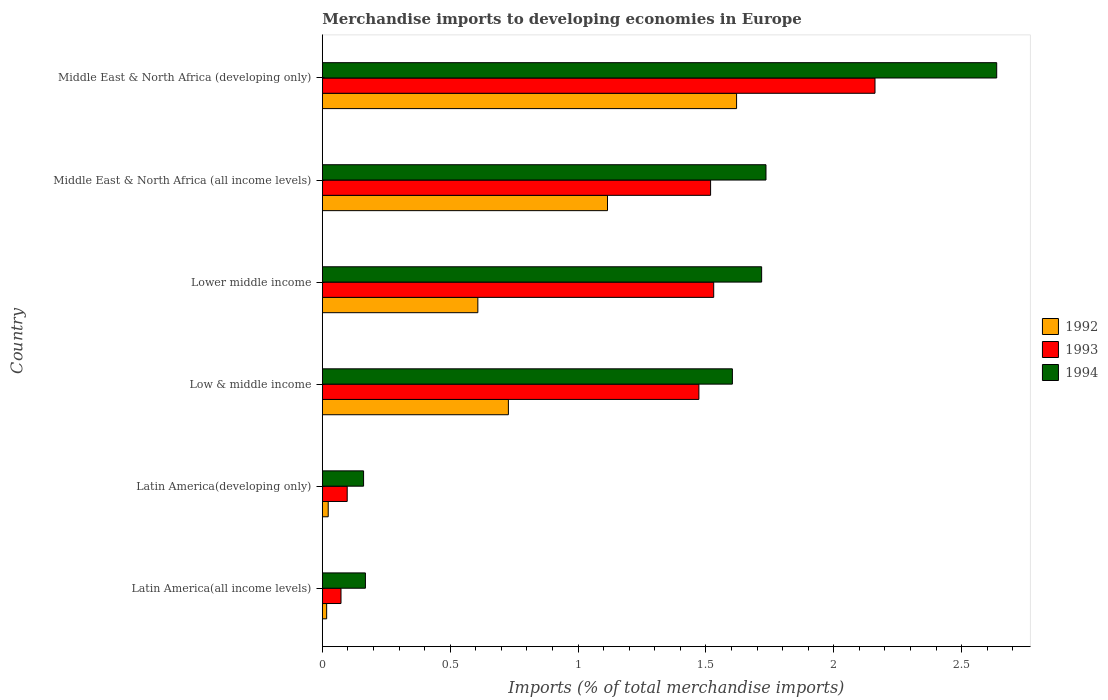How many different coloured bars are there?
Make the answer very short. 3. How many groups of bars are there?
Ensure brevity in your answer.  6. Are the number of bars per tick equal to the number of legend labels?
Ensure brevity in your answer.  Yes. How many bars are there on the 6th tick from the top?
Make the answer very short. 3. How many bars are there on the 3rd tick from the bottom?
Your response must be concise. 3. What is the label of the 3rd group of bars from the top?
Your response must be concise. Lower middle income. In how many cases, is the number of bars for a given country not equal to the number of legend labels?
Your answer should be very brief. 0. What is the percentage total merchandise imports in 1993 in Low & middle income?
Offer a very short reply. 1.47. Across all countries, what is the maximum percentage total merchandise imports in 1993?
Ensure brevity in your answer.  2.16. Across all countries, what is the minimum percentage total merchandise imports in 1994?
Provide a succinct answer. 0.16. In which country was the percentage total merchandise imports in 1994 maximum?
Offer a terse response. Middle East & North Africa (developing only). In which country was the percentage total merchandise imports in 1993 minimum?
Provide a short and direct response. Latin America(all income levels). What is the total percentage total merchandise imports in 1993 in the graph?
Your answer should be very brief. 6.85. What is the difference between the percentage total merchandise imports in 1992 in Middle East & North Africa (all income levels) and that in Middle East & North Africa (developing only)?
Give a very brief answer. -0.5. What is the difference between the percentage total merchandise imports in 1992 in Lower middle income and the percentage total merchandise imports in 1994 in Latin America(all income levels)?
Offer a very short reply. 0.44. What is the average percentage total merchandise imports in 1992 per country?
Ensure brevity in your answer.  0.69. What is the difference between the percentage total merchandise imports in 1994 and percentage total merchandise imports in 1992 in Latin America(all income levels)?
Offer a very short reply. 0.15. In how many countries, is the percentage total merchandise imports in 1992 greater than 0.5 %?
Give a very brief answer. 4. What is the ratio of the percentage total merchandise imports in 1993 in Lower middle income to that in Middle East & North Africa (developing only)?
Ensure brevity in your answer.  0.71. What is the difference between the highest and the second highest percentage total merchandise imports in 1994?
Provide a succinct answer. 0.9. What is the difference between the highest and the lowest percentage total merchandise imports in 1993?
Ensure brevity in your answer.  2.09. In how many countries, is the percentage total merchandise imports in 1993 greater than the average percentage total merchandise imports in 1993 taken over all countries?
Keep it short and to the point. 4. Is the sum of the percentage total merchandise imports in 1992 in Latin America(all income levels) and Low & middle income greater than the maximum percentage total merchandise imports in 1994 across all countries?
Make the answer very short. No. Is it the case that in every country, the sum of the percentage total merchandise imports in 1993 and percentage total merchandise imports in 1994 is greater than the percentage total merchandise imports in 1992?
Keep it short and to the point. Yes. How many bars are there?
Ensure brevity in your answer.  18. Are all the bars in the graph horizontal?
Make the answer very short. Yes. What is the difference between two consecutive major ticks on the X-axis?
Provide a short and direct response. 0.5. Does the graph contain grids?
Ensure brevity in your answer.  No. How many legend labels are there?
Offer a terse response. 3. What is the title of the graph?
Your response must be concise. Merchandise imports to developing economies in Europe. What is the label or title of the X-axis?
Offer a very short reply. Imports (% of total merchandise imports). What is the Imports (% of total merchandise imports) in 1992 in Latin America(all income levels)?
Keep it short and to the point. 0.02. What is the Imports (% of total merchandise imports) of 1993 in Latin America(all income levels)?
Give a very brief answer. 0.07. What is the Imports (% of total merchandise imports) in 1994 in Latin America(all income levels)?
Provide a short and direct response. 0.17. What is the Imports (% of total merchandise imports) of 1992 in Latin America(developing only)?
Your response must be concise. 0.02. What is the Imports (% of total merchandise imports) of 1993 in Latin America(developing only)?
Offer a terse response. 0.1. What is the Imports (% of total merchandise imports) in 1994 in Latin America(developing only)?
Offer a terse response. 0.16. What is the Imports (% of total merchandise imports) of 1992 in Low & middle income?
Make the answer very short. 0.73. What is the Imports (% of total merchandise imports) of 1993 in Low & middle income?
Offer a terse response. 1.47. What is the Imports (% of total merchandise imports) in 1994 in Low & middle income?
Your answer should be compact. 1.6. What is the Imports (% of total merchandise imports) of 1992 in Lower middle income?
Provide a succinct answer. 0.61. What is the Imports (% of total merchandise imports) in 1993 in Lower middle income?
Offer a very short reply. 1.53. What is the Imports (% of total merchandise imports) of 1994 in Lower middle income?
Make the answer very short. 1.72. What is the Imports (% of total merchandise imports) in 1992 in Middle East & North Africa (all income levels)?
Provide a succinct answer. 1.12. What is the Imports (% of total merchandise imports) of 1993 in Middle East & North Africa (all income levels)?
Make the answer very short. 1.52. What is the Imports (% of total merchandise imports) of 1994 in Middle East & North Africa (all income levels)?
Give a very brief answer. 1.74. What is the Imports (% of total merchandise imports) of 1992 in Middle East & North Africa (developing only)?
Offer a very short reply. 1.62. What is the Imports (% of total merchandise imports) in 1993 in Middle East & North Africa (developing only)?
Offer a terse response. 2.16. What is the Imports (% of total merchandise imports) of 1994 in Middle East & North Africa (developing only)?
Provide a succinct answer. 2.64. Across all countries, what is the maximum Imports (% of total merchandise imports) in 1992?
Provide a succinct answer. 1.62. Across all countries, what is the maximum Imports (% of total merchandise imports) in 1993?
Make the answer very short. 2.16. Across all countries, what is the maximum Imports (% of total merchandise imports) in 1994?
Provide a succinct answer. 2.64. Across all countries, what is the minimum Imports (% of total merchandise imports) of 1992?
Provide a succinct answer. 0.02. Across all countries, what is the minimum Imports (% of total merchandise imports) in 1993?
Your response must be concise. 0.07. Across all countries, what is the minimum Imports (% of total merchandise imports) of 1994?
Keep it short and to the point. 0.16. What is the total Imports (% of total merchandise imports) of 1992 in the graph?
Make the answer very short. 4.11. What is the total Imports (% of total merchandise imports) of 1993 in the graph?
Offer a terse response. 6.85. What is the total Imports (% of total merchandise imports) of 1994 in the graph?
Your answer should be very brief. 8.02. What is the difference between the Imports (% of total merchandise imports) of 1992 in Latin America(all income levels) and that in Latin America(developing only)?
Keep it short and to the point. -0.01. What is the difference between the Imports (% of total merchandise imports) in 1993 in Latin America(all income levels) and that in Latin America(developing only)?
Your answer should be compact. -0.02. What is the difference between the Imports (% of total merchandise imports) in 1994 in Latin America(all income levels) and that in Latin America(developing only)?
Provide a succinct answer. 0.01. What is the difference between the Imports (% of total merchandise imports) of 1992 in Latin America(all income levels) and that in Low & middle income?
Offer a terse response. -0.71. What is the difference between the Imports (% of total merchandise imports) of 1993 in Latin America(all income levels) and that in Low & middle income?
Provide a short and direct response. -1.4. What is the difference between the Imports (% of total merchandise imports) of 1994 in Latin America(all income levels) and that in Low & middle income?
Your answer should be very brief. -1.44. What is the difference between the Imports (% of total merchandise imports) in 1992 in Latin America(all income levels) and that in Lower middle income?
Offer a terse response. -0.59. What is the difference between the Imports (% of total merchandise imports) in 1993 in Latin America(all income levels) and that in Lower middle income?
Your response must be concise. -1.46. What is the difference between the Imports (% of total merchandise imports) in 1994 in Latin America(all income levels) and that in Lower middle income?
Provide a short and direct response. -1.55. What is the difference between the Imports (% of total merchandise imports) in 1992 in Latin America(all income levels) and that in Middle East & North Africa (all income levels)?
Keep it short and to the point. -1.1. What is the difference between the Imports (% of total merchandise imports) of 1993 in Latin America(all income levels) and that in Middle East & North Africa (all income levels)?
Provide a succinct answer. -1.45. What is the difference between the Imports (% of total merchandise imports) of 1994 in Latin America(all income levels) and that in Middle East & North Africa (all income levels)?
Your answer should be very brief. -1.57. What is the difference between the Imports (% of total merchandise imports) in 1992 in Latin America(all income levels) and that in Middle East & North Africa (developing only)?
Your answer should be compact. -1.6. What is the difference between the Imports (% of total merchandise imports) of 1993 in Latin America(all income levels) and that in Middle East & North Africa (developing only)?
Provide a succinct answer. -2.09. What is the difference between the Imports (% of total merchandise imports) in 1994 in Latin America(all income levels) and that in Middle East & North Africa (developing only)?
Keep it short and to the point. -2.47. What is the difference between the Imports (% of total merchandise imports) of 1992 in Latin America(developing only) and that in Low & middle income?
Keep it short and to the point. -0.7. What is the difference between the Imports (% of total merchandise imports) of 1993 in Latin America(developing only) and that in Low & middle income?
Provide a succinct answer. -1.38. What is the difference between the Imports (% of total merchandise imports) in 1994 in Latin America(developing only) and that in Low & middle income?
Provide a succinct answer. -1.44. What is the difference between the Imports (% of total merchandise imports) of 1992 in Latin America(developing only) and that in Lower middle income?
Provide a short and direct response. -0.59. What is the difference between the Imports (% of total merchandise imports) in 1993 in Latin America(developing only) and that in Lower middle income?
Provide a succinct answer. -1.43. What is the difference between the Imports (% of total merchandise imports) in 1994 in Latin America(developing only) and that in Lower middle income?
Offer a terse response. -1.56. What is the difference between the Imports (% of total merchandise imports) in 1992 in Latin America(developing only) and that in Middle East & North Africa (all income levels)?
Provide a short and direct response. -1.09. What is the difference between the Imports (% of total merchandise imports) of 1993 in Latin America(developing only) and that in Middle East & North Africa (all income levels)?
Keep it short and to the point. -1.42. What is the difference between the Imports (% of total merchandise imports) in 1994 in Latin America(developing only) and that in Middle East & North Africa (all income levels)?
Offer a terse response. -1.57. What is the difference between the Imports (% of total merchandise imports) of 1992 in Latin America(developing only) and that in Middle East & North Africa (developing only)?
Provide a succinct answer. -1.6. What is the difference between the Imports (% of total merchandise imports) of 1993 in Latin America(developing only) and that in Middle East & North Africa (developing only)?
Keep it short and to the point. -2.06. What is the difference between the Imports (% of total merchandise imports) of 1994 in Latin America(developing only) and that in Middle East & North Africa (developing only)?
Your answer should be very brief. -2.48. What is the difference between the Imports (% of total merchandise imports) of 1992 in Low & middle income and that in Lower middle income?
Your answer should be compact. 0.12. What is the difference between the Imports (% of total merchandise imports) in 1993 in Low & middle income and that in Lower middle income?
Ensure brevity in your answer.  -0.06. What is the difference between the Imports (% of total merchandise imports) of 1994 in Low & middle income and that in Lower middle income?
Your answer should be compact. -0.11. What is the difference between the Imports (% of total merchandise imports) in 1992 in Low & middle income and that in Middle East & North Africa (all income levels)?
Offer a very short reply. -0.39. What is the difference between the Imports (% of total merchandise imports) of 1993 in Low & middle income and that in Middle East & North Africa (all income levels)?
Offer a terse response. -0.05. What is the difference between the Imports (% of total merchandise imports) of 1994 in Low & middle income and that in Middle East & North Africa (all income levels)?
Keep it short and to the point. -0.13. What is the difference between the Imports (% of total merchandise imports) in 1992 in Low & middle income and that in Middle East & North Africa (developing only)?
Keep it short and to the point. -0.89. What is the difference between the Imports (% of total merchandise imports) of 1993 in Low & middle income and that in Middle East & North Africa (developing only)?
Your answer should be very brief. -0.69. What is the difference between the Imports (% of total merchandise imports) in 1994 in Low & middle income and that in Middle East & North Africa (developing only)?
Offer a very short reply. -1.03. What is the difference between the Imports (% of total merchandise imports) in 1992 in Lower middle income and that in Middle East & North Africa (all income levels)?
Provide a short and direct response. -0.51. What is the difference between the Imports (% of total merchandise imports) in 1993 in Lower middle income and that in Middle East & North Africa (all income levels)?
Give a very brief answer. 0.01. What is the difference between the Imports (% of total merchandise imports) in 1994 in Lower middle income and that in Middle East & North Africa (all income levels)?
Give a very brief answer. -0.02. What is the difference between the Imports (% of total merchandise imports) in 1992 in Lower middle income and that in Middle East & North Africa (developing only)?
Your answer should be compact. -1.01. What is the difference between the Imports (% of total merchandise imports) in 1993 in Lower middle income and that in Middle East & North Africa (developing only)?
Provide a succinct answer. -0.63. What is the difference between the Imports (% of total merchandise imports) in 1994 in Lower middle income and that in Middle East & North Africa (developing only)?
Give a very brief answer. -0.92. What is the difference between the Imports (% of total merchandise imports) of 1992 in Middle East & North Africa (all income levels) and that in Middle East & North Africa (developing only)?
Provide a short and direct response. -0.5. What is the difference between the Imports (% of total merchandise imports) of 1993 in Middle East & North Africa (all income levels) and that in Middle East & North Africa (developing only)?
Give a very brief answer. -0.64. What is the difference between the Imports (% of total merchandise imports) in 1994 in Middle East & North Africa (all income levels) and that in Middle East & North Africa (developing only)?
Your answer should be very brief. -0.9. What is the difference between the Imports (% of total merchandise imports) of 1992 in Latin America(all income levels) and the Imports (% of total merchandise imports) of 1993 in Latin America(developing only)?
Your answer should be compact. -0.08. What is the difference between the Imports (% of total merchandise imports) of 1992 in Latin America(all income levels) and the Imports (% of total merchandise imports) of 1994 in Latin America(developing only)?
Offer a terse response. -0.14. What is the difference between the Imports (% of total merchandise imports) in 1993 in Latin America(all income levels) and the Imports (% of total merchandise imports) in 1994 in Latin America(developing only)?
Offer a very short reply. -0.09. What is the difference between the Imports (% of total merchandise imports) in 1992 in Latin America(all income levels) and the Imports (% of total merchandise imports) in 1993 in Low & middle income?
Your response must be concise. -1.46. What is the difference between the Imports (% of total merchandise imports) of 1992 in Latin America(all income levels) and the Imports (% of total merchandise imports) of 1994 in Low & middle income?
Keep it short and to the point. -1.59. What is the difference between the Imports (% of total merchandise imports) in 1993 in Latin America(all income levels) and the Imports (% of total merchandise imports) in 1994 in Low & middle income?
Your answer should be compact. -1.53. What is the difference between the Imports (% of total merchandise imports) in 1992 in Latin America(all income levels) and the Imports (% of total merchandise imports) in 1993 in Lower middle income?
Offer a very short reply. -1.51. What is the difference between the Imports (% of total merchandise imports) in 1992 in Latin America(all income levels) and the Imports (% of total merchandise imports) in 1994 in Lower middle income?
Provide a short and direct response. -1.7. What is the difference between the Imports (% of total merchandise imports) of 1993 in Latin America(all income levels) and the Imports (% of total merchandise imports) of 1994 in Lower middle income?
Make the answer very short. -1.65. What is the difference between the Imports (% of total merchandise imports) of 1992 in Latin America(all income levels) and the Imports (% of total merchandise imports) of 1993 in Middle East & North Africa (all income levels)?
Ensure brevity in your answer.  -1.5. What is the difference between the Imports (% of total merchandise imports) in 1992 in Latin America(all income levels) and the Imports (% of total merchandise imports) in 1994 in Middle East & North Africa (all income levels)?
Offer a terse response. -1.72. What is the difference between the Imports (% of total merchandise imports) of 1993 in Latin America(all income levels) and the Imports (% of total merchandise imports) of 1994 in Middle East & North Africa (all income levels)?
Your response must be concise. -1.66. What is the difference between the Imports (% of total merchandise imports) of 1992 in Latin America(all income levels) and the Imports (% of total merchandise imports) of 1993 in Middle East & North Africa (developing only)?
Ensure brevity in your answer.  -2.14. What is the difference between the Imports (% of total merchandise imports) of 1992 in Latin America(all income levels) and the Imports (% of total merchandise imports) of 1994 in Middle East & North Africa (developing only)?
Keep it short and to the point. -2.62. What is the difference between the Imports (% of total merchandise imports) in 1993 in Latin America(all income levels) and the Imports (% of total merchandise imports) in 1994 in Middle East & North Africa (developing only)?
Give a very brief answer. -2.56. What is the difference between the Imports (% of total merchandise imports) in 1992 in Latin America(developing only) and the Imports (% of total merchandise imports) in 1993 in Low & middle income?
Your answer should be very brief. -1.45. What is the difference between the Imports (% of total merchandise imports) in 1992 in Latin America(developing only) and the Imports (% of total merchandise imports) in 1994 in Low & middle income?
Offer a terse response. -1.58. What is the difference between the Imports (% of total merchandise imports) of 1993 in Latin America(developing only) and the Imports (% of total merchandise imports) of 1994 in Low & middle income?
Your response must be concise. -1.51. What is the difference between the Imports (% of total merchandise imports) of 1992 in Latin America(developing only) and the Imports (% of total merchandise imports) of 1993 in Lower middle income?
Provide a short and direct response. -1.51. What is the difference between the Imports (% of total merchandise imports) of 1992 in Latin America(developing only) and the Imports (% of total merchandise imports) of 1994 in Lower middle income?
Provide a short and direct response. -1.7. What is the difference between the Imports (% of total merchandise imports) of 1993 in Latin America(developing only) and the Imports (% of total merchandise imports) of 1994 in Lower middle income?
Give a very brief answer. -1.62. What is the difference between the Imports (% of total merchandise imports) of 1992 in Latin America(developing only) and the Imports (% of total merchandise imports) of 1993 in Middle East & North Africa (all income levels)?
Your response must be concise. -1.5. What is the difference between the Imports (% of total merchandise imports) in 1992 in Latin America(developing only) and the Imports (% of total merchandise imports) in 1994 in Middle East & North Africa (all income levels)?
Provide a short and direct response. -1.71. What is the difference between the Imports (% of total merchandise imports) in 1993 in Latin America(developing only) and the Imports (% of total merchandise imports) in 1994 in Middle East & North Africa (all income levels)?
Your answer should be compact. -1.64. What is the difference between the Imports (% of total merchandise imports) of 1992 in Latin America(developing only) and the Imports (% of total merchandise imports) of 1993 in Middle East & North Africa (developing only)?
Keep it short and to the point. -2.14. What is the difference between the Imports (% of total merchandise imports) of 1992 in Latin America(developing only) and the Imports (% of total merchandise imports) of 1994 in Middle East & North Africa (developing only)?
Give a very brief answer. -2.61. What is the difference between the Imports (% of total merchandise imports) of 1993 in Latin America(developing only) and the Imports (% of total merchandise imports) of 1994 in Middle East & North Africa (developing only)?
Provide a short and direct response. -2.54. What is the difference between the Imports (% of total merchandise imports) of 1992 in Low & middle income and the Imports (% of total merchandise imports) of 1993 in Lower middle income?
Offer a terse response. -0.8. What is the difference between the Imports (% of total merchandise imports) of 1992 in Low & middle income and the Imports (% of total merchandise imports) of 1994 in Lower middle income?
Your response must be concise. -0.99. What is the difference between the Imports (% of total merchandise imports) in 1993 in Low & middle income and the Imports (% of total merchandise imports) in 1994 in Lower middle income?
Provide a succinct answer. -0.25. What is the difference between the Imports (% of total merchandise imports) in 1992 in Low & middle income and the Imports (% of total merchandise imports) in 1993 in Middle East & North Africa (all income levels)?
Make the answer very short. -0.79. What is the difference between the Imports (% of total merchandise imports) of 1992 in Low & middle income and the Imports (% of total merchandise imports) of 1994 in Middle East & North Africa (all income levels)?
Your answer should be very brief. -1.01. What is the difference between the Imports (% of total merchandise imports) of 1993 in Low & middle income and the Imports (% of total merchandise imports) of 1994 in Middle East & North Africa (all income levels)?
Ensure brevity in your answer.  -0.26. What is the difference between the Imports (% of total merchandise imports) in 1992 in Low & middle income and the Imports (% of total merchandise imports) in 1993 in Middle East & North Africa (developing only)?
Your answer should be very brief. -1.43. What is the difference between the Imports (% of total merchandise imports) in 1992 in Low & middle income and the Imports (% of total merchandise imports) in 1994 in Middle East & North Africa (developing only)?
Offer a terse response. -1.91. What is the difference between the Imports (% of total merchandise imports) of 1993 in Low & middle income and the Imports (% of total merchandise imports) of 1994 in Middle East & North Africa (developing only)?
Give a very brief answer. -1.16. What is the difference between the Imports (% of total merchandise imports) of 1992 in Lower middle income and the Imports (% of total merchandise imports) of 1993 in Middle East & North Africa (all income levels)?
Provide a succinct answer. -0.91. What is the difference between the Imports (% of total merchandise imports) in 1992 in Lower middle income and the Imports (% of total merchandise imports) in 1994 in Middle East & North Africa (all income levels)?
Keep it short and to the point. -1.13. What is the difference between the Imports (% of total merchandise imports) in 1993 in Lower middle income and the Imports (% of total merchandise imports) in 1994 in Middle East & North Africa (all income levels)?
Your answer should be compact. -0.2. What is the difference between the Imports (% of total merchandise imports) of 1992 in Lower middle income and the Imports (% of total merchandise imports) of 1993 in Middle East & North Africa (developing only)?
Offer a very short reply. -1.55. What is the difference between the Imports (% of total merchandise imports) in 1992 in Lower middle income and the Imports (% of total merchandise imports) in 1994 in Middle East & North Africa (developing only)?
Provide a succinct answer. -2.03. What is the difference between the Imports (% of total merchandise imports) in 1993 in Lower middle income and the Imports (% of total merchandise imports) in 1994 in Middle East & North Africa (developing only)?
Provide a short and direct response. -1.11. What is the difference between the Imports (% of total merchandise imports) in 1992 in Middle East & North Africa (all income levels) and the Imports (% of total merchandise imports) in 1993 in Middle East & North Africa (developing only)?
Your answer should be very brief. -1.05. What is the difference between the Imports (% of total merchandise imports) in 1992 in Middle East & North Africa (all income levels) and the Imports (% of total merchandise imports) in 1994 in Middle East & North Africa (developing only)?
Your response must be concise. -1.52. What is the difference between the Imports (% of total merchandise imports) in 1993 in Middle East & North Africa (all income levels) and the Imports (% of total merchandise imports) in 1994 in Middle East & North Africa (developing only)?
Keep it short and to the point. -1.12. What is the average Imports (% of total merchandise imports) of 1992 per country?
Your answer should be compact. 0.69. What is the average Imports (% of total merchandise imports) in 1993 per country?
Offer a terse response. 1.14. What is the average Imports (% of total merchandise imports) in 1994 per country?
Keep it short and to the point. 1.34. What is the difference between the Imports (% of total merchandise imports) of 1992 and Imports (% of total merchandise imports) of 1993 in Latin America(all income levels)?
Ensure brevity in your answer.  -0.06. What is the difference between the Imports (% of total merchandise imports) of 1992 and Imports (% of total merchandise imports) of 1994 in Latin America(all income levels)?
Offer a very short reply. -0.15. What is the difference between the Imports (% of total merchandise imports) in 1993 and Imports (% of total merchandise imports) in 1994 in Latin America(all income levels)?
Offer a very short reply. -0.1. What is the difference between the Imports (% of total merchandise imports) in 1992 and Imports (% of total merchandise imports) in 1993 in Latin America(developing only)?
Offer a very short reply. -0.07. What is the difference between the Imports (% of total merchandise imports) of 1992 and Imports (% of total merchandise imports) of 1994 in Latin America(developing only)?
Offer a very short reply. -0.14. What is the difference between the Imports (% of total merchandise imports) of 1993 and Imports (% of total merchandise imports) of 1994 in Latin America(developing only)?
Provide a short and direct response. -0.06. What is the difference between the Imports (% of total merchandise imports) of 1992 and Imports (% of total merchandise imports) of 1993 in Low & middle income?
Your answer should be compact. -0.74. What is the difference between the Imports (% of total merchandise imports) in 1992 and Imports (% of total merchandise imports) in 1994 in Low & middle income?
Your answer should be very brief. -0.88. What is the difference between the Imports (% of total merchandise imports) of 1993 and Imports (% of total merchandise imports) of 1994 in Low & middle income?
Your answer should be very brief. -0.13. What is the difference between the Imports (% of total merchandise imports) in 1992 and Imports (% of total merchandise imports) in 1993 in Lower middle income?
Your response must be concise. -0.92. What is the difference between the Imports (% of total merchandise imports) of 1992 and Imports (% of total merchandise imports) of 1994 in Lower middle income?
Provide a succinct answer. -1.11. What is the difference between the Imports (% of total merchandise imports) of 1993 and Imports (% of total merchandise imports) of 1994 in Lower middle income?
Provide a short and direct response. -0.19. What is the difference between the Imports (% of total merchandise imports) of 1992 and Imports (% of total merchandise imports) of 1993 in Middle East & North Africa (all income levels)?
Your answer should be very brief. -0.4. What is the difference between the Imports (% of total merchandise imports) in 1992 and Imports (% of total merchandise imports) in 1994 in Middle East & North Africa (all income levels)?
Your answer should be very brief. -0.62. What is the difference between the Imports (% of total merchandise imports) of 1993 and Imports (% of total merchandise imports) of 1994 in Middle East & North Africa (all income levels)?
Provide a succinct answer. -0.22. What is the difference between the Imports (% of total merchandise imports) of 1992 and Imports (% of total merchandise imports) of 1993 in Middle East & North Africa (developing only)?
Make the answer very short. -0.54. What is the difference between the Imports (% of total merchandise imports) of 1992 and Imports (% of total merchandise imports) of 1994 in Middle East & North Africa (developing only)?
Your answer should be very brief. -1.02. What is the difference between the Imports (% of total merchandise imports) in 1993 and Imports (% of total merchandise imports) in 1994 in Middle East & North Africa (developing only)?
Offer a very short reply. -0.48. What is the ratio of the Imports (% of total merchandise imports) in 1992 in Latin America(all income levels) to that in Latin America(developing only)?
Make the answer very short. 0.73. What is the ratio of the Imports (% of total merchandise imports) in 1993 in Latin America(all income levels) to that in Latin America(developing only)?
Make the answer very short. 0.75. What is the ratio of the Imports (% of total merchandise imports) of 1994 in Latin America(all income levels) to that in Latin America(developing only)?
Offer a very short reply. 1.04. What is the ratio of the Imports (% of total merchandise imports) in 1992 in Latin America(all income levels) to that in Low & middle income?
Your answer should be compact. 0.02. What is the ratio of the Imports (% of total merchandise imports) of 1993 in Latin America(all income levels) to that in Low & middle income?
Provide a succinct answer. 0.05. What is the ratio of the Imports (% of total merchandise imports) of 1994 in Latin America(all income levels) to that in Low & middle income?
Your response must be concise. 0.11. What is the ratio of the Imports (% of total merchandise imports) in 1992 in Latin America(all income levels) to that in Lower middle income?
Provide a short and direct response. 0.03. What is the ratio of the Imports (% of total merchandise imports) in 1993 in Latin America(all income levels) to that in Lower middle income?
Your response must be concise. 0.05. What is the ratio of the Imports (% of total merchandise imports) in 1994 in Latin America(all income levels) to that in Lower middle income?
Ensure brevity in your answer.  0.1. What is the ratio of the Imports (% of total merchandise imports) of 1992 in Latin America(all income levels) to that in Middle East & North Africa (all income levels)?
Ensure brevity in your answer.  0.02. What is the ratio of the Imports (% of total merchandise imports) of 1993 in Latin America(all income levels) to that in Middle East & North Africa (all income levels)?
Make the answer very short. 0.05. What is the ratio of the Imports (% of total merchandise imports) in 1994 in Latin America(all income levels) to that in Middle East & North Africa (all income levels)?
Provide a succinct answer. 0.1. What is the ratio of the Imports (% of total merchandise imports) of 1992 in Latin America(all income levels) to that in Middle East & North Africa (developing only)?
Ensure brevity in your answer.  0.01. What is the ratio of the Imports (% of total merchandise imports) of 1993 in Latin America(all income levels) to that in Middle East & North Africa (developing only)?
Your answer should be compact. 0.03. What is the ratio of the Imports (% of total merchandise imports) of 1994 in Latin America(all income levels) to that in Middle East & North Africa (developing only)?
Give a very brief answer. 0.06. What is the ratio of the Imports (% of total merchandise imports) in 1992 in Latin America(developing only) to that in Low & middle income?
Your answer should be very brief. 0.03. What is the ratio of the Imports (% of total merchandise imports) in 1993 in Latin America(developing only) to that in Low & middle income?
Provide a short and direct response. 0.07. What is the ratio of the Imports (% of total merchandise imports) in 1994 in Latin America(developing only) to that in Low & middle income?
Offer a very short reply. 0.1. What is the ratio of the Imports (% of total merchandise imports) in 1992 in Latin America(developing only) to that in Lower middle income?
Your answer should be very brief. 0.04. What is the ratio of the Imports (% of total merchandise imports) of 1993 in Latin America(developing only) to that in Lower middle income?
Offer a terse response. 0.06. What is the ratio of the Imports (% of total merchandise imports) of 1994 in Latin America(developing only) to that in Lower middle income?
Ensure brevity in your answer.  0.09. What is the ratio of the Imports (% of total merchandise imports) in 1992 in Latin America(developing only) to that in Middle East & North Africa (all income levels)?
Your response must be concise. 0.02. What is the ratio of the Imports (% of total merchandise imports) of 1993 in Latin America(developing only) to that in Middle East & North Africa (all income levels)?
Offer a very short reply. 0.06. What is the ratio of the Imports (% of total merchandise imports) of 1994 in Latin America(developing only) to that in Middle East & North Africa (all income levels)?
Give a very brief answer. 0.09. What is the ratio of the Imports (% of total merchandise imports) of 1992 in Latin America(developing only) to that in Middle East & North Africa (developing only)?
Make the answer very short. 0.01. What is the ratio of the Imports (% of total merchandise imports) of 1993 in Latin America(developing only) to that in Middle East & North Africa (developing only)?
Provide a succinct answer. 0.04. What is the ratio of the Imports (% of total merchandise imports) in 1994 in Latin America(developing only) to that in Middle East & North Africa (developing only)?
Make the answer very short. 0.06. What is the ratio of the Imports (% of total merchandise imports) of 1992 in Low & middle income to that in Lower middle income?
Ensure brevity in your answer.  1.2. What is the ratio of the Imports (% of total merchandise imports) in 1993 in Low & middle income to that in Lower middle income?
Ensure brevity in your answer.  0.96. What is the ratio of the Imports (% of total merchandise imports) in 1994 in Low & middle income to that in Lower middle income?
Offer a terse response. 0.93. What is the ratio of the Imports (% of total merchandise imports) in 1992 in Low & middle income to that in Middle East & North Africa (all income levels)?
Keep it short and to the point. 0.65. What is the ratio of the Imports (% of total merchandise imports) in 1993 in Low & middle income to that in Middle East & North Africa (all income levels)?
Your answer should be very brief. 0.97. What is the ratio of the Imports (% of total merchandise imports) in 1994 in Low & middle income to that in Middle East & North Africa (all income levels)?
Your answer should be compact. 0.92. What is the ratio of the Imports (% of total merchandise imports) of 1992 in Low & middle income to that in Middle East & North Africa (developing only)?
Your answer should be compact. 0.45. What is the ratio of the Imports (% of total merchandise imports) of 1993 in Low & middle income to that in Middle East & North Africa (developing only)?
Your response must be concise. 0.68. What is the ratio of the Imports (% of total merchandise imports) of 1994 in Low & middle income to that in Middle East & North Africa (developing only)?
Provide a succinct answer. 0.61. What is the ratio of the Imports (% of total merchandise imports) in 1992 in Lower middle income to that in Middle East & North Africa (all income levels)?
Your answer should be compact. 0.55. What is the ratio of the Imports (% of total merchandise imports) of 1993 in Lower middle income to that in Middle East & North Africa (all income levels)?
Make the answer very short. 1.01. What is the ratio of the Imports (% of total merchandise imports) in 1994 in Lower middle income to that in Middle East & North Africa (all income levels)?
Ensure brevity in your answer.  0.99. What is the ratio of the Imports (% of total merchandise imports) in 1992 in Lower middle income to that in Middle East & North Africa (developing only)?
Offer a terse response. 0.38. What is the ratio of the Imports (% of total merchandise imports) in 1993 in Lower middle income to that in Middle East & North Africa (developing only)?
Keep it short and to the point. 0.71. What is the ratio of the Imports (% of total merchandise imports) of 1994 in Lower middle income to that in Middle East & North Africa (developing only)?
Offer a terse response. 0.65. What is the ratio of the Imports (% of total merchandise imports) of 1992 in Middle East & North Africa (all income levels) to that in Middle East & North Africa (developing only)?
Make the answer very short. 0.69. What is the ratio of the Imports (% of total merchandise imports) in 1993 in Middle East & North Africa (all income levels) to that in Middle East & North Africa (developing only)?
Your answer should be compact. 0.7. What is the ratio of the Imports (% of total merchandise imports) of 1994 in Middle East & North Africa (all income levels) to that in Middle East & North Africa (developing only)?
Keep it short and to the point. 0.66. What is the difference between the highest and the second highest Imports (% of total merchandise imports) of 1992?
Offer a very short reply. 0.5. What is the difference between the highest and the second highest Imports (% of total merchandise imports) in 1993?
Give a very brief answer. 0.63. What is the difference between the highest and the second highest Imports (% of total merchandise imports) of 1994?
Offer a terse response. 0.9. What is the difference between the highest and the lowest Imports (% of total merchandise imports) of 1992?
Your response must be concise. 1.6. What is the difference between the highest and the lowest Imports (% of total merchandise imports) of 1993?
Your answer should be compact. 2.09. What is the difference between the highest and the lowest Imports (% of total merchandise imports) in 1994?
Offer a very short reply. 2.48. 